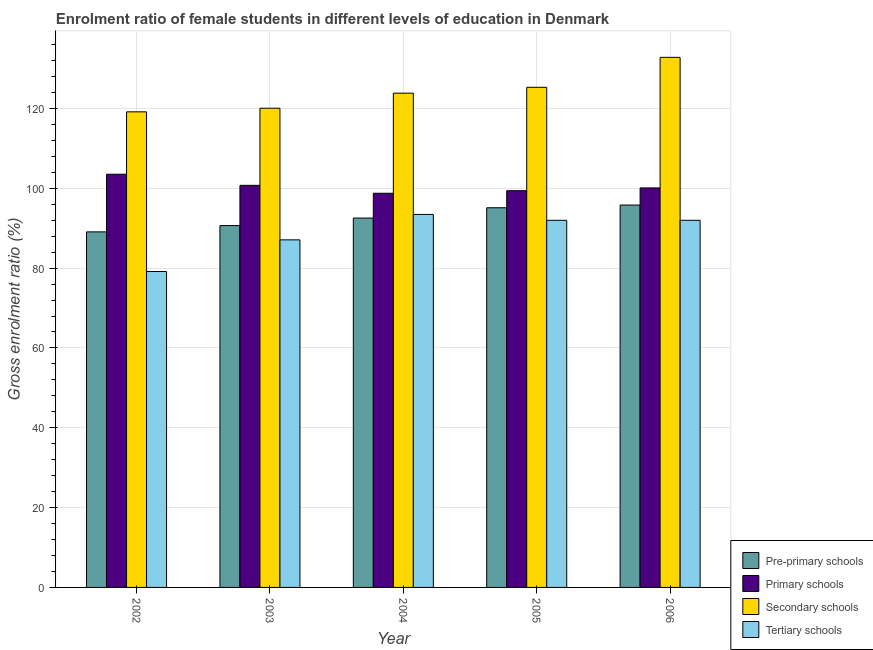How many different coloured bars are there?
Offer a terse response. 4. How many groups of bars are there?
Provide a succinct answer. 5. Are the number of bars per tick equal to the number of legend labels?
Ensure brevity in your answer.  Yes. Are the number of bars on each tick of the X-axis equal?
Provide a short and direct response. Yes. How many bars are there on the 2nd tick from the left?
Provide a short and direct response. 4. How many bars are there on the 1st tick from the right?
Offer a terse response. 4. What is the gross enrolment ratio(male) in tertiary schools in 2003?
Give a very brief answer. 87.08. Across all years, what is the maximum gross enrolment ratio(male) in primary schools?
Ensure brevity in your answer.  103.53. Across all years, what is the minimum gross enrolment ratio(male) in pre-primary schools?
Your response must be concise. 89.08. In which year was the gross enrolment ratio(male) in secondary schools minimum?
Your response must be concise. 2002. What is the total gross enrolment ratio(male) in tertiary schools in the graph?
Your response must be concise. 443.64. What is the difference between the gross enrolment ratio(male) in secondary schools in 2004 and that in 2005?
Ensure brevity in your answer.  -1.47. What is the difference between the gross enrolment ratio(male) in tertiary schools in 2002 and the gross enrolment ratio(male) in secondary schools in 2006?
Give a very brief answer. -12.83. What is the average gross enrolment ratio(male) in primary schools per year?
Your answer should be compact. 100.5. In the year 2003, what is the difference between the gross enrolment ratio(male) in pre-primary schools and gross enrolment ratio(male) in primary schools?
Offer a terse response. 0. What is the ratio of the gross enrolment ratio(male) in primary schools in 2002 to that in 2003?
Make the answer very short. 1.03. What is the difference between the highest and the second highest gross enrolment ratio(male) in tertiary schools?
Make the answer very short. 1.47. What is the difference between the highest and the lowest gross enrolment ratio(male) in primary schools?
Your response must be concise. 4.77. Is the sum of the gross enrolment ratio(male) in pre-primary schools in 2002 and 2003 greater than the maximum gross enrolment ratio(male) in primary schools across all years?
Give a very brief answer. Yes. What does the 1st bar from the left in 2003 represents?
Your answer should be compact. Pre-primary schools. What does the 1st bar from the right in 2002 represents?
Your answer should be compact. Tertiary schools. Does the graph contain any zero values?
Your answer should be very brief. No. Does the graph contain grids?
Your answer should be compact. Yes. How many legend labels are there?
Make the answer very short. 4. How are the legend labels stacked?
Ensure brevity in your answer.  Vertical. What is the title of the graph?
Offer a very short reply. Enrolment ratio of female students in different levels of education in Denmark. Does "Revenue mobilization" appear as one of the legend labels in the graph?
Give a very brief answer. No. What is the label or title of the Y-axis?
Provide a succinct answer. Gross enrolment ratio (%). What is the Gross enrolment ratio (%) in Pre-primary schools in 2002?
Offer a very short reply. 89.08. What is the Gross enrolment ratio (%) in Primary schools in 2002?
Offer a very short reply. 103.53. What is the Gross enrolment ratio (%) of Secondary schools in 2002?
Offer a very short reply. 119.16. What is the Gross enrolment ratio (%) of Tertiary schools in 2002?
Provide a short and direct response. 79.15. What is the Gross enrolment ratio (%) in Pre-primary schools in 2003?
Provide a short and direct response. 90.66. What is the Gross enrolment ratio (%) of Primary schools in 2003?
Your response must be concise. 100.74. What is the Gross enrolment ratio (%) in Secondary schools in 2003?
Make the answer very short. 120.06. What is the Gross enrolment ratio (%) in Tertiary schools in 2003?
Offer a very short reply. 87.08. What is the Gross enrolment ratio (%) of Pre-primary schools in 2004?
Offer a very short reply. 92.54. What is the Gross enrolment ratio (%) in Primary schools in 2004?
Keep it short and to the point. 98.76. What is the Gross enrolment ratio (%) of Secondary schools in 2004?
Offer a very short reply. 123.83. What is the Gross enrolment ratio (%) of Tertiary schools in 2004?
Make the answer very short. 93.45. What is the Gross enrolment ratio (%) in Pre-primary schools in 2005?
Give a very brief answer. 95.12. What is the Gross enrolment ratio (%) in Primary schools in 2005?
Ensure brevity in your answer.  99.4. What is the Gross enrolment ratio (%) of Secondary schools in 2005?
Keep it short and to the point. 125.3. What is the Gross enrolment ratio (%) in Tertiary schools in 2005?
Your answer should be compact. 91.98. What is the Gross enrolment ratio (%) in Pre-primary schools in 2006?
Your answer should be compact. 95.8. What is the Gross enrolment ratio (%) of Primary schools in 2006?
Give a very brief answer. 100.1. What is the Gross enrolment ratio (%) of Secondary schools in 2006?
Provide a short and direct response. 132.81. What is the Gross enrolment ratio (%) in Tertiary schools in 2006?
Make the answer very short. 91.98. Across all years, what is the maximum Gross enrolment ratio (%) of Pre-primary schools?
Offer a very short reply. 95.8. Across all years, what is the maximum Gross enrolment ratio (%) of Primary schools?
Your answer should be compact. 103.53. Across all years, what is the maximum Gross enrolment ratio (%) in Secondary schools?
Your answer should be compact. 132.81. Across all years, what is the maximum Gross enrolment ratio (%) of Tertiary schools?
Keep it short and to the point. 93.45. Across all years, what is the minimum Gross enrolment ratio (%) of Pre-primary schools?
Ensure brevity in your answer.  89.08. Across all years, what is the minimum Gross enrolment ratio (%) in Primary schools?
Offer a terse response. 98.76. Across all years, what is the minimum Gross enrolment ratio (%) of Secondary schools?
Provide a short and direct response. 119.16. Across all years, what is the minimum Gross enrolment ratio (%) in Tertiary schools?
Keep it short and to the point. 79.15. What is the total Gross enrolment ratio (%) in Pre-primary schools in the graph?
Make the answer very short. 463.21. What is the total Gross enrolment ratio (%) in Primary schools in the graph?
Your answer should be very brief. 502.52. What is the total Gross enrolment ratio (%) in Secondary schools in the graph?
Provide a succinct answer. 621.16. What is the total Gross enrolment ratio (%) in Tertiary schools in the graph?
Provide a short and direct response. 443.64. What is the difference between the Gross enrolment ratio (%) of Pre-primary schools in 2002 and that in 2003?
Your answer should be very brief. -1.58. What is the difference between the Gross enrolment ratio (%) in Primary schools in 2002 and that in 2003?
Offer a terse response. 2.78. What is the difference between the Gross enrolment ratio (%) of Secondary schools in 2002 and that in 2003?
Provide a succinct answer. -0.9. What is the difference between the Gross enrolment ratio (%) in Tertiary schools in 2002 and that in 2003?
Provide a succinct answer. -7.93. What is the difference between the Gross enrolment ratio (%) in Pre-primary schools in 2002 and that in 2004?
Keep it short and to the point. -3.46. What is the difference between the Gross enrolment ratio (%) of Primary schools in 2002 and that in 2004?
Your answer should be compact. 4.77. What is the difference between the Gross enrolment ratio (%) in Secondary schools in 2002 and that in 2004?
Offer a terse response. -4.68. What is the difference between the Gross enrolment ratio (%) in Tertiary schools in 2002 and that in 2004?
Ensure brevity in your answer.  -14.3. What is the difference between the Gross enrolment ratio (%) in Pre-primary schools in 2002 and that in 2005?
Offer a very short reply. -6.04. What is the difference between the Gross enrolment ratio (%) in Primary schools in 2002 and that in 2005?
Ensure brevity in your answer.  4.13. What is the difference between the Gross enrolment ratio (%) in Secondary schools in 2002 and that in 2005?
Provide a short and direct response. -6.15. What is the difference between the Gross enrolment ratio (%) in Tertiary schools in 2002 and that in 2005?
Your answer should be compact. -12.83. What is the difference between the Gross enrolment ratio (%) in Pre-primary schools in 2002 and that in 2006?
Provide a short and direct response. -6.72. What is the difference between the Gross enrolment ratio (%) in Primary schools in 2002 and that in 2006?
Offer a very short reply. 3.43. What is the difference between the Gross enrolment ratio (%) of Secondary schools in 2002 and that in 2006?
Your answer should be compact. -13.65. What is the difference between the Gross enrolment ratio (%) of Tertiary schools in 2002 and that in 2006?
Ensure brevity in your answer.  -12.83. What is the difference between the Gross enrolment ratio (%) in Pre-primary schools in 2003 and that in 2004?
Ensure brevity in your answer.  -1.88. What is the difference between the Gross enrolment ratio (%) of Primary schools in 2003 and that in 2004?
Your answer should be very brief. 1.99. What is the difference between the Gross enrolment ratio (%) in Secondary schools in 2003 and that in 2004?
Your answer should be compact. -3.77. What is the difference between the Gross enrolment ratio (%) of Tertiary schools in 2003 and that in 2004?
Ensure brevity in your answer.  -6.37. What is the difference between the Gross enrolment ratio (%) of Pre-primary schools in 2003 and that in 2005?
Provide a short and direct response. -4.46. What is the difference between the Gross enrolment ratio (%) of Primary schools in 2003 and that in 2005?
Your answer should be compact. 1.34. What is the difference between the Gross enrolment ratio (%) in Secondary schools in 2003 and that in 2005?
Offer a terse response. -5.24. What is the difference between the Gross enrolment ratio (%) of Tertiary schools in 2003 and that in 2005?
Your response must be concise. -4.9. What is the difference between the Gross enrolment ratio (%) in Pre-primary schools in 2003 and that in 2006?
Provide a succinct answer. -5.14. What is the difference between the Gross enrolment ratio (%) of Primary schools in 2003 and that in 2006?
Offer a very short reply. 0.65. What is the difference between the Gross enrolment ratio (%) of Secondary schools in 2003 and that in 2006?
Offer a terse response. -12.75. What is the difference between the Gross enrolment ratio (%) of Tertiary schools in 2003 and that in 2006?
Provide a short and direct response. -4.9. What is the difference between the Gross enrolment ratio (%) of Pre-primary schools in 2004 and that in 2005?
Ensure brevity in your answer.  -2.58. What is the difference between the Gross enrolment ratio (%) in Primary schools in 2004 and that in 2005?
Make the answer very short. -0.64. What is the difference between the Gross enrolment ratio (%) in Secondary schools in 2004 and that in 2005?
Your answer should be very brief. -1.47. What is the difference between the Gross enrolment ratio (%) in Tertiary schools in 2004 and that in 2005?
Offer a very short reply. 1.47. What is the difference between the Gross enrolment ratio (%) in Pre-primary schools in 2004 and that in 2006?
Your answer should be compact. -3.26. What is the difference between the Gross enrolment ratio (%) of Primary schools in 2004 and that in 2006?
Ensure brevity in your answer.  -1.34. What is the difference between the Gross enrolment ratio (%) of Secondary schools in 2004 and that in 2006?
Offer a terse response. -8.98. What is the difference between the Gross enrolment ratio (%) of Tertiary schools in 2004 and that in 2006?
Your response must be concise. 1.47. What is the difference between the Gross enrolment ratio (%) of Pre-primary schools in 2005 and that in 2006?
Provide a short and direct response. -0.68. What is the difference between the Gross enrolment ratio (%) of Primary schools in 2005 and that in 2006?
Offer a very short reply. -0.7. What is the difference between the Gross enrolment ratio (%) of Secondary schools in 2005 and that in 2006?
Make the answer very short. -7.51. What is the difference between the Gross enrolment ratio (%) in Tertiary schools in 2005 and that in 2006?
Ensure brevity in your answer.  -0. What is the difference between the Gross enrolment ratio (%) in Pre-primary schools in 2002 and the Gross enrolment ratio (%) in Primary schools in 2003?
Your answer should be compact. -11.66. What is the difference between the Gross enrolment ratio (%) of Pre-primary schools in 2002 and the Gross enrolment ratio (%) of Secondary schools in 2003?
Offer a terse response. -30.98. What is the difference between the Gross enrolment ratio (%) in Pre-primary schools in 2002 and the Gross enrolment ratio (%) in Tertiary schools in 2003?
Ensure brevity in your answer.  2. What is the difference between the Gross enrolment ratio (%) in Primary schools in 2002 and the Gross enrolment ratio (%) in Secondary schools in 2003?
Keep it short and to the point. -16.54. What is the difference between the Gross enrolment ratio (%) in Primary schools in 2002 and the Gross enrolment ratio (%) in Tertiary schools in 2003?
Offer a terse response. 16.44. What is the difference between the Gross enrolment ratio (%) in Secondary schools in 2002 and the Gross enrolment ratio (%) in Tertiary schools in 2003?
Your answer should be compact. 32.08. What is the difference between the Gross enrolment ratio (%) in Pre-primary schools in 2002 and the Gross enrolment ratio (%) in Primary schools in 2004?
Provide a short and direct response. -9.67. What is the difference between the Gross enrolment ratio (%) of Pre-primary schools in 2002 and the Gross enrolment ratio (%) of Secondary schools in 2004?
Keep it short and to the point. -34.75. What is the difference between the Gross enrolment ratio (%) of Pre-primary schools in 2002 and the Gross enrolment ratio (%) of Tertiary schools in 2004?
Keep it short and to the point. -4.37. What is the difference between the Gross enrolment ratio (%) of Primary schools in 2002 and the Gross enrolment ratio (%) of Secondary schools in 2004?
Provide a short and direct response. -20.31. What is the difference between the Gross enrolment ratio (%) in Primary schools in 2002 and the Gross enrolment ratio (%) in Tertiary schools in 2004?
Provide a succinct answer. 10.07. What is the difference between the Gross enrolment ratio (%) of Secondary schools in 2002 and the Gross enrolment ratio (%) of Tertiary schools in 2004?
Offer a terse response. 25.71. What is the difference between the Gross enrolment ratio (%) of Pre-primary schools in 2002 and the Gross enrolment ratio (%) of Primary schools in 2005?
Provide a succinct answer. -10.32. What is the difference between the Gross enrolment ratio (%) of Pre-primary schools in 2002 and the Gross enrolment ratio (%) of Secondary schools in 2005?
Keep it short and to the point. -36.22. What is the difference between the Gross enrolment ratio (%) in Pre-primary schools in 2002 and the Gross enrolment ratio (%) in Tertiary schools in 2005?
Provide a succinct answer. -2.9. What is the difference between the Gross enrolment ratio (%) in Primary schools in 2002 and the Gross enrolment ratio (%) in Secondary schools in 2005?
Provide a succinct answer. -21.78. What is the difference between the Gross enrolment ratio (%) of Primary schools in 2002 and the Gross enrolment ratio (%) of Tertiary schools in 2005?
Keep it short and to the point. 11.54. What is the difference between the Gross enrolment ratio (%) in Secondary schools in 2002 and the Gross enrolment ratio (%) in Tertiary schools in 2005?
Your answer should be compact. 27.18. What is the difference between the Gross enrolment ratio (%) in Pre-primary schools in 2002 and the Gross enrolment ratio (%) in Primary schools in 2006?
Provide a succinct answer. -11.01. What is the difference between the Gross enrolment ratio (%) of Pre-primary schools in 2002 and the Gross enrolment ratio (%) of Secondary schools in 2006?
Offer a very short reply. -43.73. What is the difference between the Gross enrolment ratio (%) of Pre-primary schools in 2002 and the Gross enrolment ratio (%) of Tertiary schools in 2006?
Your answer should be compact. -2.9. What is the difference between the Gross enrolment ratio (%) of Primary schools in 2002 and the Gross enrolment ratio (%) of Secondary schools in 2006?
Provide a succinct answer. -29.29. What is the difference between the Gross enrolment ratio (%) in Primary schools in 2002 and the Gross enrolment ratio (%) in Tertiary schools in 2006?
Provide a short and direct response. 11.54. What is the difference between the Gross enrolment ratio (%) of Secondary schools in 2002 and the Gross enrolment ratio (%) of Tertiary schools in 2006?
Your answer should be compact. 27.17. What is the difference between the Gross enrolment ratio (%) of Pre-primary schools in 2003 and the Gross enrolment ratio (%) of Primary schools in 2004?
Give a very brief answer. -8.1. What is the difference between the Gross enrolment ratio (%) in Pre-primary schools in 2003 and the Gross enrolment ratio (%) in Secondary schools in 2004?
Your answer should be compact. -33.17. What is the difference between the Gross enrolment ratio (%) of Pre-primary schools in 2003 and the Gross enrolment ratio (%) of Tertiary schools in 2004?
Your answer should be very brief. -2.79. What is the difference between the Gross enrolment ratio (%) in Primary schools in 2003 and the Gross enrolment ratio (%) in Secondary schools in 2004?
Provide a succinct answer. -23.09. What is the difference between the Gross enrolment ratio (%) in Primary schools in 2003 and the Gross enrolment ratio (%) in Tertiary schools in 2004?
Ensure brevity in your answer.  7.29. What is the difference between the Gross enrolment ratio (%) in Secondary schools in 2003 and the Gross enrolment ratio (%) in Tertiary schools in 2004?
Your response must be concise. 26.61. What is the difference between the Gross enrolment ratio (%) in Pre-primary schools in 2003 and the Gross enrolment ratio (%) in Primary schools in 2005?
Your answer should be compact. -8.74. What is the difference between the Gross enrolment ratio (%) of Pre-primary schools in 2003 and the Gross enrolment ratio (%) of Secondary schools in 2005?
Offer a very short reply. -34.64. What is the difference between the Gross enrolment ratio (%) of Pre-primary schools in 2003 and the Gross enrolment ratio (%) of Tertiary schools in 2005?
Offer a very short reply. -1.32. What is the difference between the Gross enrolment ratio (%) in Primary schools in 2003 and the Gross enrolment ratio (%) in Secondary schools in 2005?
Offer a terse response. -24.56. What is the difference between the Gross enrolment ratio (%) in Primary schools in 2003 and the Gross enrolment ratio (%) in Tertiary schools in 2005?
Make the answer very short. 8.76. What is the difference between the Gross enrolment ratio (%) in Secondary schools in 2003 and the Gross enrolment ratio (%) in Tertiary schools in 2005?
Ensure brevity in your answer.  28.08. What is the difference between the Gross enrolment ratio (%) of Pre-primary schools in 2003 and the Gross enrolment ratio (%) of Primary schools in 2006?
Offer a very short reply. -9.44. What is the difference between the Gross enrolment ratio (%) of Pre-primary schools in 2003 and the Gross enrolment ratio (%) of Secondary schools in 2006?
Give a very brief answer. -42.15. What is the difference between the Gross enrolment ratio (%) in Pre-primary schools in 2003 and the Gross enrolment ratio (%) in Tertiary schools in 2006?
Keep it short and to the point. -1.32. What is the difference between the Gross enrolment ratio (%) of Primary schools in 2003 and the Gross enrolment ratio (%) of Secondary schools in 2006?
Your answer should be compact. -32.07. What is the difference between the Gross enrolment ratio (%) of Primary schools in 2003 and the Gross enrolment ratio (%) of Tertiary schools in 2006?
Keep it short and to the point. 8.76. What is the difference between the Gross enrolment ratio (%) of Secondary schools in 2003 and the Gross enrolment ratio (%) of Tertiary schools in 2006?
Keep it short and to the point. 28.08. What is the difference between the Gross enrolment ratio (%) of Pre-primary schools in 2004 and the Gross enrolment ratio (%) of Primary schools in 2005?
Keep it short and to the point. -6.85. What is the difference between the Gross enrolment ratio (%) in Pre-primary schools in 2004 and the Gross enrolment ratio (%) in Secondary schools in 2005?
Make the answer very short. -32.76. What is the difference between the Gross enrolment ratio (%) in Pre-primary schools in 2004 and the Gross enrolment ratio (%) in Tertiary schools in 2005?
Offer a very short reply. 0.56. What is the difference between the Gross enrolment ratio (%) in Primary schools in 2004 and the Gross enrolment ratio (%) in Secondary schools in 2005?
Offer a terse response. -26.55. What is the difference between the Gross enrolment ratio (%) of Primary schools in 2004 and the Gross enrolment ratio (%) of Tertiary schools in 2005?
Offer a terse response. 6.78. What is the difference between the Gross enrolment ratio (%) in Secondary schools in 2004 and the Gross enrolment ratio (%) in Tertiary schools in 2005?
Offer a very short reply. 31.85. What is the difference between the Gross enrolment ratio (%) in Pre-primary schools in 2004 and the Gross enrolment ratio (%) in Primary schools in 2006?
Offer a terse response. -7.55. What is the difference between the Gross enrolment ratio (%) in Pre-primary schools in 2004 and the Gross enrolment ratio (%) in Secondary schools in 2006?
Provide a short and direct response. -40.27. What is the difference between the Gross enrolment ratio (%) of Pre-primary schools in 2004 and the Gross enrolment ratio (%) of Tertiary schools in 2006?
Give a very brief answer. 0.56. What is the difference between the Gross enrolment ratio (%) in Primary schools in 2004 and the Gross enrolment ratio (%) in Secondary schools in 2006?
Provide a short and direct response. -34.05. What is the difference between the Gross enrolment ratio (%) of Primary schools in 2004 and the Gross enrolment ratio (%) of Tertiary schools in 2006?
Your answer should be very brief. 6.77. What is the difference between the Gross enrolment ratio (%) of Secondary schools in 2004 and the Gross enrolment ratio (%) of Tertiary schools in 2006?
Make the answer very short. 31.85. What is the difference between the Gross enrolment ratio (%) of Pre-primary schools in 2005 and the Gross enrolment ratio (%) of Primary schools in 2006?
Your answer should be compact. -4.97. What is the difference between the Gross enrolment ratio (%) of Pre-primary schools in 2005 and the Gross enrolment ratio (%) of Secondary schools in 2006?
Give a very brief answer. -37.69. What is the difference between the Gross enrolment ratio (%) of Pre-primary schools in 2005 and the Gross enrolment ratio (%) of Tertiary schools in 2006?
Offer a very short reply. 3.14. What is the difference between the Gross enrolment ratio (%) of Primary schools in 2005 and the Gross enrolment ratio (%) of Secondary schools in 2006?
Your answer should be compact. -33.41. What is the difference between the Gross enrolment ratio (%) in Primary schools in 2005 and the Gross enrolment ratio (%) in Tertiary schools in 2006?
Keep it short and to the point. 7.42. What is the difference between the Gross enrolment ratio (%) of Secondary schools in 2005 and the Gross enrolment ratio (%) of Tertiary schools in 2006?
Provide a short and direct response. 33.32. What is the average Gross enrolment ratio (%) of Pre-primary schools per year?
Make the answer very short. 92.64. What is the average Gross enrolment ratio (%) in Primary schools per year?
Give a very brief answer. 100.5. What is the average Gross enrolment ratio (%) in Secondary schools per year?
Offer a terse response. 124.23. What is the average Gross enrolment ratio (%) in Tertiary schools per year?
Your answer should be compact. 88.73. In the year 2002, what is the difference between the Gross enrolment ratio (%) of Pre-primary schools and Gross enrolment ratio (%) of Primary schools?
Make the answer very short. -14.44. In the year 2002, what is the difference between the Gross enrolment ratio (%) in Pre-primary schools and Gross enrolment ratio (%) in Secondary schools?
Your answer should be compact. -30.07. In the year 2002, what is the difference between the Gross enrolment ratio (%) of Pre-primary schools and Gross enrolment ratio (%) of Tertiary schools?
Keep it short and to the point. 9.93. In the year 2002, what is the difference between the Gross enrolment ratio (%) of Primary schools and Gross enrolment ratio (%) of Secondary schools?
Offer a very short reply. -15.63. In the year 2002, what is the difference between the Gross enrolment ratio (%) in Primary schools and Gross enrolment ratio (%) in Tertiary schools?
Offer a terse response. 24.37. In the year 2002, what is the difference between the Gross enrolment ratio (%) in Secondary schools and Gross enrolment ratio (%) in Tertiary schools?
Make the answer very short. 40.01. In the year 2003, what is the difference between the Gross enrolment ratio (%) of Pre-primary schools and Gross enrolment ratio (%) of Primary schools?
Your answer should be compact. -10.08. In the year 2003, what is the difference between the Gross enrolment ratio (%) in Pre-primary schools and Gross enrolment ratio (%) in Secondary schools?
Your response must be concise. -29.4. In the year 2003, what is the difference between the Gross enrolment ratio (%) in Pre-primary schools and Gross enrolment ratio (%) in Tertiary schools?
Give a very brief answer. 3.58. In the year 2003, what is the difference between the Gross enrolment ratio (%) of Primary schools and Gross enrolment ratio (%) of Secondary schools?
Provide a succinct answer. -19.32. In the year 2003, what is the difference between the Gross enrolment ratio (%) in Primary schools and Gross enrolment ratio (%) in Tertiary schools?
Ensure brevity in your answer.  13.66. In the year 2003, what is the difference between the Gross enrolment ratio (%) in Secondary schools and Gross enrolment ratio (%) in Tertiary schools?
Give a very brief answer. 32.98. In the year 2004, what is the difference between the Gross enrolment ratio (%) in Pre-primary schools and Gross enrolment ratio (%) in Primary schools?
Give a very brief answer. -6.21. In the year 2004, what is the difference between the Gross enrolment ratio (%) in Pre-primary schools and Gross enrolment ratio (%) in Secondary schools?
Your response must be concise. -31.29. In the year 2004, what is the difference between the Gross enrolment ratio (%) in Pre-primary schools and Gross enrolment ratio (%) in Tertiary schools?
Your response must be concise. -0.91. In the year 2004, what is the difference between the Gross enrolment ratio (%) of Primary schools and Gross enrolment ratio (%) of Secondary schools?
Provide a short and direct response. -25.08. In the year 2004, what is the difference between the Gross enrolment ratio (%) of Primary schools and Gross enrolment ratio (%) of Tertiary schools?
Your answer should be compact. 5.31. In the year 2004, what is the difference between the Gross enrolment ratio (%) in Secondary schools and Gross enrolment ratio (%) in Tertiary schools?
Your response must be concise. 30.38. In the year 2005, what is the difference between the Gross enrolment ratio (%) in Pre-primary schools and Gross enrolment ratio (%) in Primary schools?
Make the answer very short. -4.28. In the year 2005, what is the difference between the Gross enrolment ratio (%) in Pre-primary schools and Gross enrolment ratio (%) in Secondary schools?
Provide a succinct answer. -30.18. In the year 2005, what is the difference between the Gross enrolment ratio (%) of Pre-primary schools and Gross enrolment ratio (%) of Tertiary schools?
Provide a short and direct response. 3.14. In the year 2005, what is the difference between the Gross enrolment ratio (%) of Primary schools and Gross enrolment ratio (%) of Secondary schools?
Offer a very short reply. -25.9. In the year 2005, what is the difference between the Gross enrolment ratio (%) of Primary schools and Gross enrolment ratio (%) of Tertiary schools?
Provide a succinct answer. 7.42. In the year 2005, what is the difference between the Gross enrolment ratio (%) of Secondary schools and Gross enrolment ratio (%) of Tertiary schools?
Offer a terse response. 33.32. In the year 2006, what is the difference between the Gross enrolment ratio (%) in Pre-primary schools and Gross enrolment ratio (%) in Primary schools?
Provide a succinct answer. -4.29. In the year 2006, what is the difference between the Gross enrolment ratio (%) in Pre-primary schools and Gross enrolment ratio (%) in Secondary schools?
Offer a terse response. -37.01. In the year 2006, what is the difference between the Gross enrolment ratio (%) of Pre-primary schools and Gross enrolment ratio (%) of Tertiary schools?
Offer a very short reply. 3.82. In the year 2006, what is the difference between the Gross enrolment ratio (%) in Primary schools and Gross enrolment ratio (%) in Secondary schools?
Offer a terse response. -32.72. In the year 2006, what is the difference between the Gross enrolment ratio (%) of Primary schools and Gross enrolment ratio (%) of Tertiary schools?
Make the answer very short. 8.11. In the year 2006, what is the difference between the Gross enrolment ratio (%) of Secondary schools and Gross enrolment ratio (%) of Tertiary schools?
Provide a short and direct response. 40.83. What is the ratio of the Gross enrolment ratio (%) in Pre-primary schools in 2002 to that in 2003?
Your response must be concise. 0.98. What is the ratio of the Gross enrolment ratio (%) of Primary schools in 2002 to that in 2003?
Your answer should be very brief. 1.03. What is the ratio of the Gross enrolment ratio (%) in Tertiary schools in 2002 to that in 2003?
Provide a succinct answer. 0.91. What is the ratio of the Gross enrolment ratio (%) in Pre-primary schools in 2002 to that in 2004?
Offer a terse response. 0.96. What is the ratio of the Gross enrolment ratio (%) in Primary schools in 2002 to that in 2004?
Give a very brief answer. 1.05. What is the ratio of the Gross enrolment ratio (%) of Secondary schools in 2002 to that in 2004?
Provide a short and direct response. 0.96. What is the ratio of the Gross enrolment ratio (%) of Tertiary schools in 2002 to that in 2004?
Ensure brevity in your answer.  0.85. What is the ratio of the Gross enrolment ratio (%) of Pre-primary schools in 2002 to that in 2005?
Offer a very short reply. 0.94. What is the ratio of the Gross enrolment ratio (%) in Primary schools in 2002 to that in 2005?
Your answer should be very brief. 1.04. What is the ratio of the Gross enrolment ratio (%) of Secondary schools in 2002 to that in 2005?
Keep it short and to the point. 0.95. What is the ratio of the Gross enrolment ratio (%) in Tertiary schools in 2002 to that in 2005?
Provide a short and direct response. 0.86. What is the ratio of the Gross enrolment ratio (%) in Pre-primary schools in 2002 to that in 2006?
Your response must be concise. 0.93. What is the ratio of the Gross enrolment ratio (%) of Primary schools in 2002 to that in 2006?
Make the answer very short. 1.03. What is the ratio of the Gross enrolment ratio (%) in Secondary schools in 2002 to that in 2006?
Give a very brief answer. 0.9. What is the ratio of the Gross enrolment ratio (%) in Tertiary schools in 2002 to that in 2006?
Your answer should be very brief. 0.86. What is the ratio of the Gross enrolment ratio (%) of Pre-primary schools in 2003 to that in 2004?
Provide a succinct answer. 0.98. What is the ratio of the Gross enrolment ratio (%) of Primary schools in 2003 to that in 2004?
Your answer should be compact. 1.02. What is the ratio of the Gross enrolment ratio (%) in Secondary schools in 2003 to that in 2004?
Your answer should be compact. 0.97. What is the ratio of the Gross enrolment ratio (%) in Tertiary schools in 2003 to that in 2004?
Your answer should be very brief. 0.93. What is the ratio of the Gross enrolment ratio (%) in Pre-primary schools in 2003 to that in 2005?
Your answer should be compact. 0.95. What is the ratio of the Gross enrolment ratio (%) in Primary schools in 2003 to that in 2005?
Ensure brevity in your answer.  1.01. What is the ratio of the Gross enrolment ratio (%) of Secondary schools in 2003 to that in 2005?
Your answer should be compact. 0.96. What is the ratio of the Gross enrolment ratio (%) of Tertiary schools in 2003 to that in 2005?
Keep it short and to the point. 0.95. What is the ratio of the Gross enrolment ratio (%) in Pre-primary schools in 2003 to that in 2006?
Offer a terse response. 0.95. What is the ratio of the Gross enrolment ratio (%) of Secondary schools in 2003 to that in 2006?
Your response must be concise. 0.9. What is the ratio of the Gross enrolment ratio (%) in Tertiary schools in 2003 to that in 2006?
Make the answer very short. 0.95. What is the ratio of the Gross enrolment ratio (%) of Pre-primary schools in 2004 to that in 2005?
Offer a very short reply. 0.97. What is the ratio of the Gross enrolment ratio (%) of Primary schools in 2004 to that in 2005?
Provide a succinct answer. 0.99. What is the ratio of the Gross enrolment ratio (%) in Secondary schools in 2004 to that in 2005?
Offer a terse response. 0.99. What is the ratio of the Gross enrolment ratio (%) of Pre-primary schools in 2004 to that in 2006?
Your answer should be very brief. 0.97. What is the ratio of the Gross enrolment ratio (%) in Primary schools in 2004 to that in 2006?
Give a very brief answer. 0.99. What is the ratio of the Gross enrolment ratio (%) in Secondary schools in 2004 to that in 2006?
Ensure brevity in your answer.  0.93. What is the ratio of the Gross enrolment ratio (%) of Pre-primary schools in 2005 to that in 2006?
Offer a terse response. 0.99. What is the ratio of the Gross enrolment ratio (%) of Primary schools in 2005 to that in 2006?
Make the answer very short. 0.99. What is the ratio of the Gross enrolment ratio (%) of Secondary schools in 2005 to that in 2006?
Ensure brevity in your answer.  0.94. What is the difference between the highest and the second highest Gross enrolment ratio (%) in Pre-primary schools?
Give a very brief answer. 0.68. What is the difference between the highest and the second highest Gross enrolment ratio (%) of Primary schools?
Keep it short and to the point. 2.78. What is the difference between the highest and the second highest Gross enrolment ratio (%) in Secondary schools?
Your answer should be compact. 7.51. What is the difference between the highest and the second highest Gross enrolment ratio (%) of Tertiary schools?
Your answer should be very brief. 1.47. What is the difference between the highest and the lowest Gross enrolment ratio (%) in Pre-primary schools?
Make the answer very short. 6.72. What is the difference between the highest and the lowest Gross enrolment ratio (%) of Primary schools?
Provide a short and direct response. 4.77. What is the difference between the highest and the lowest Gross enrolment ratio (%) of Secondary schools?
Make the answer very short. 13.65. What is the difference between the highest and the lowest Gross enrolment ratio (%) in Tertiary schools?
Provide a succinct answer. 14.3. 